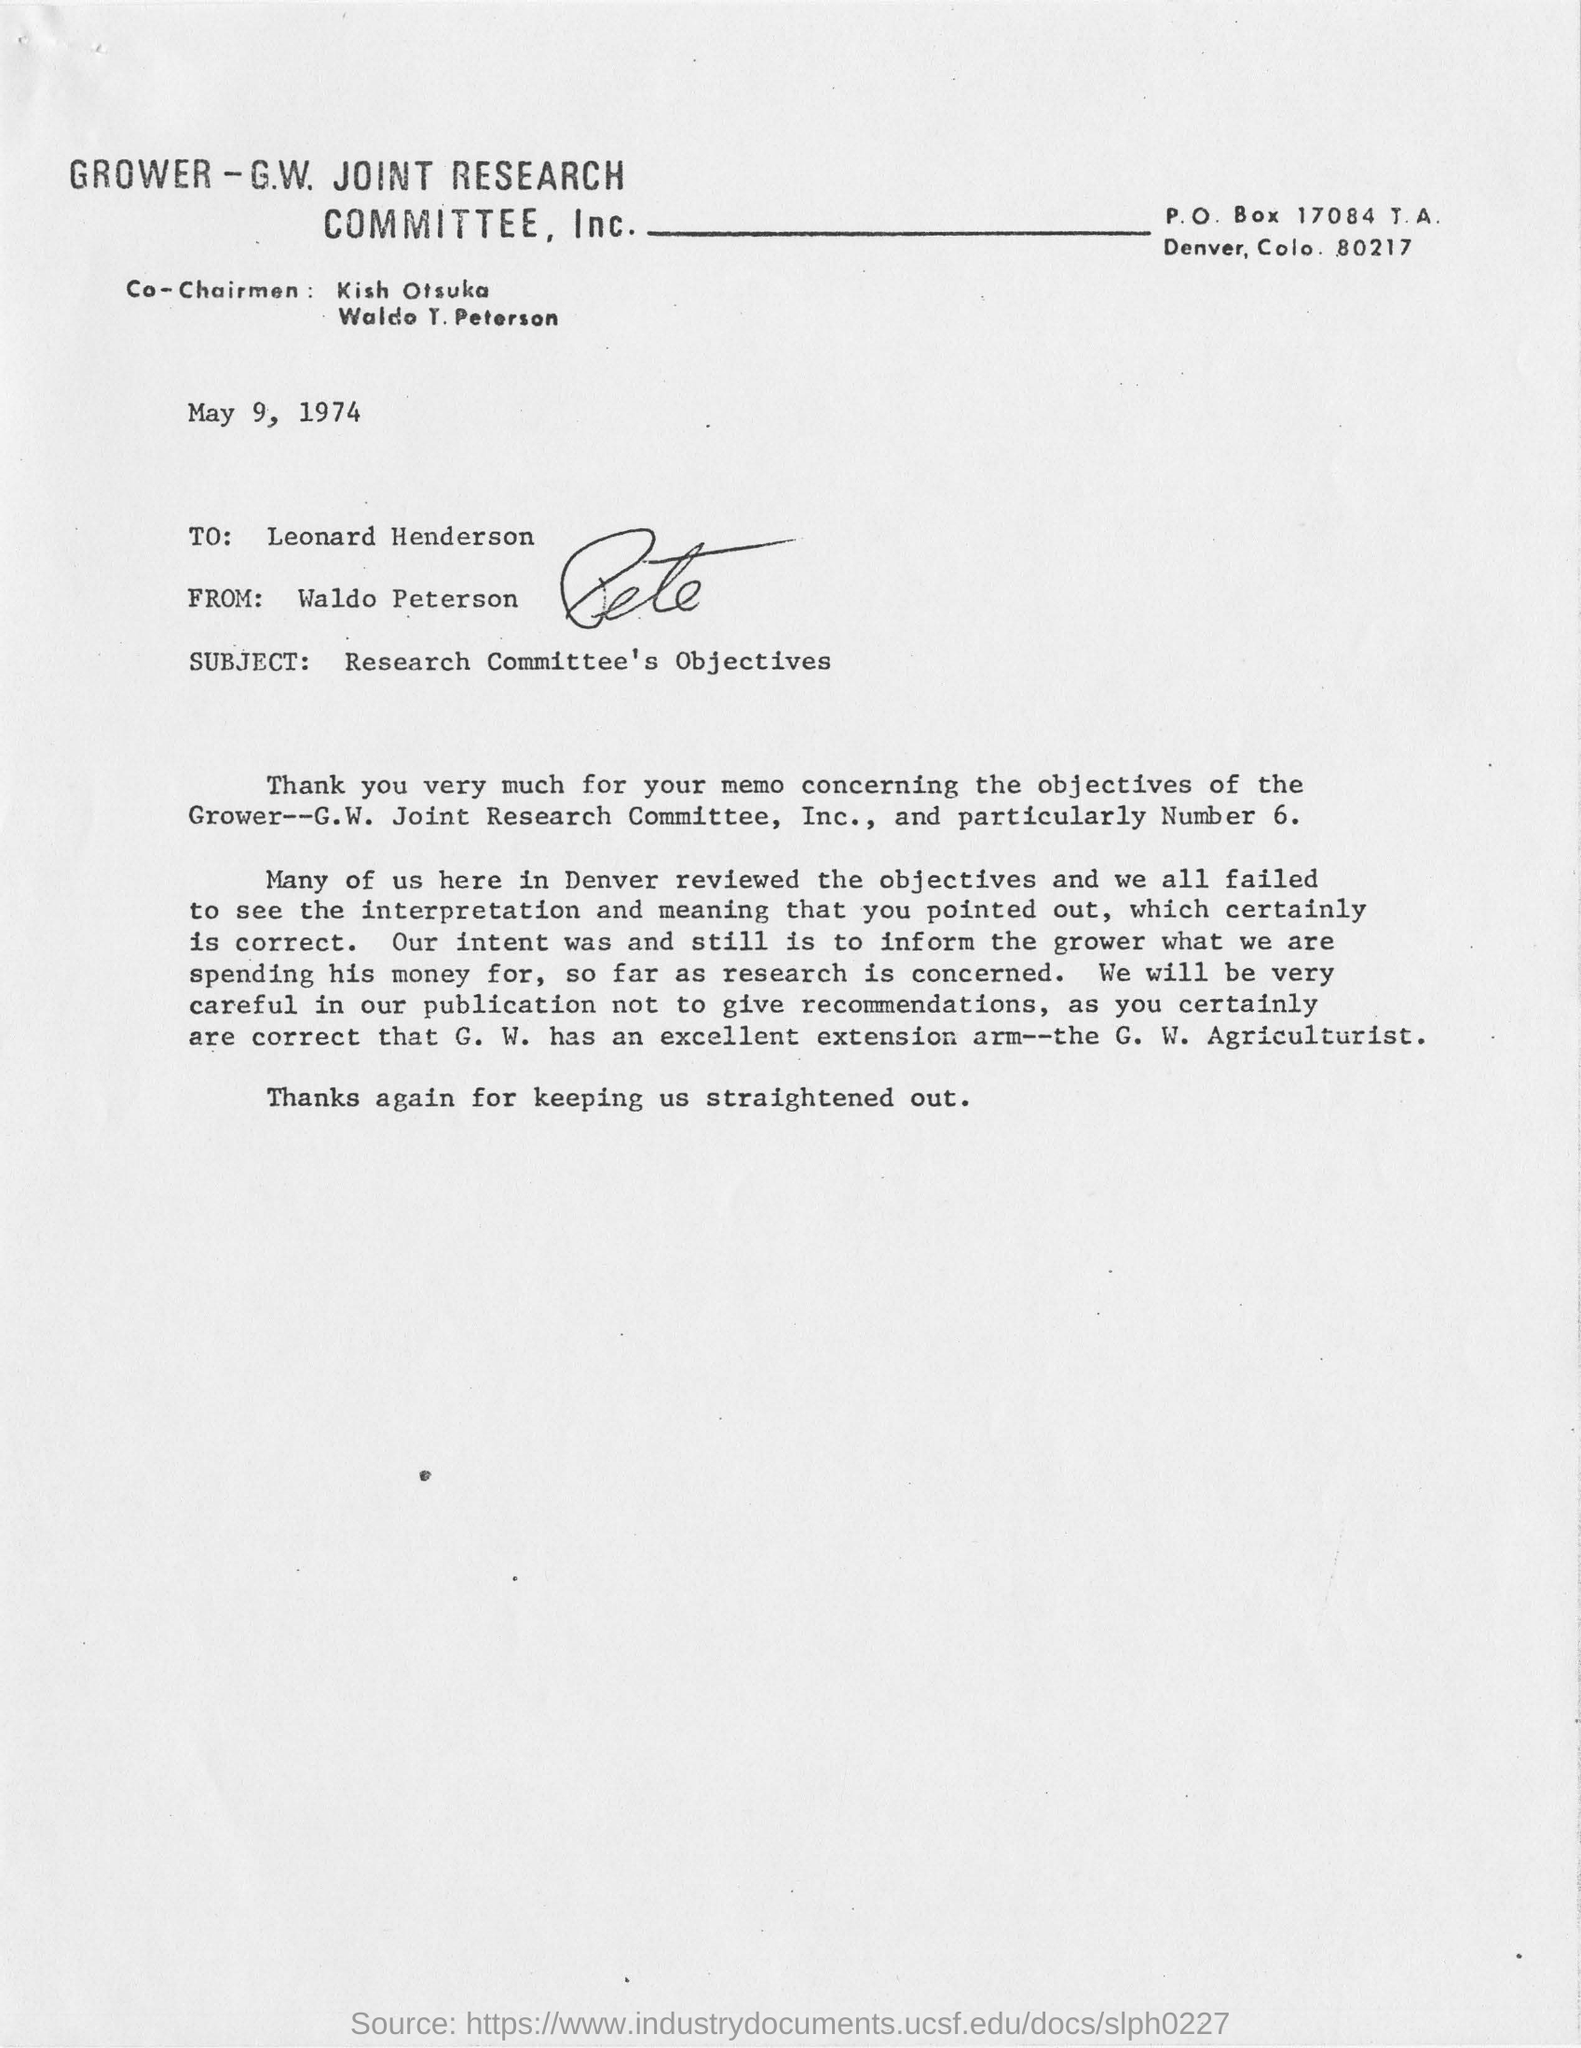What is the subject of this memo?
Provide a succinct answer. Research Committee's Objectives. What is the date of the document
Provide a succinct answer. May 9, 1974. Who is receiver of letter?
Make the answer very short. Leonard henderson. What is the subject of this letter?
Give a very brief answer. Research committee's objectives. 